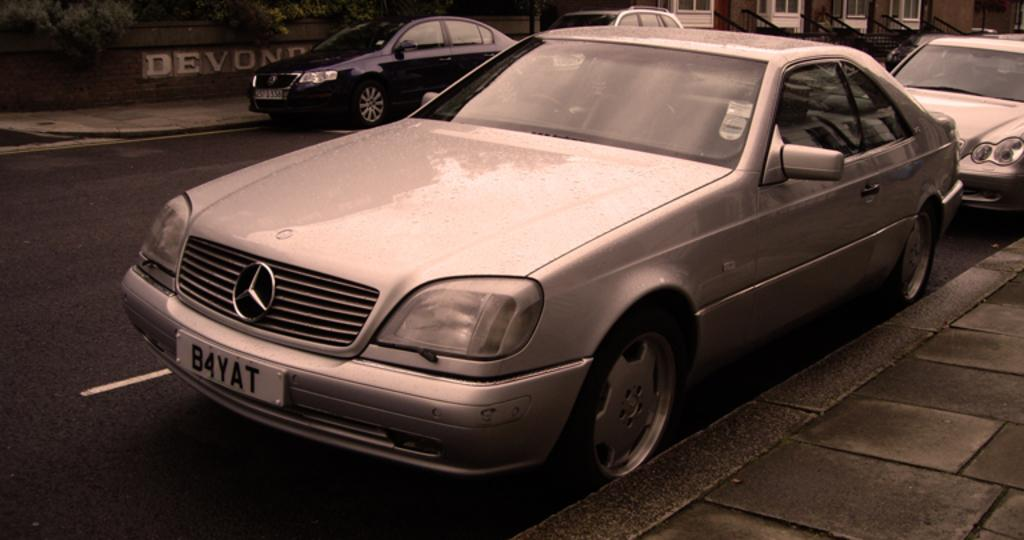<image>
Give a short and clear explanation of the subsequent image. A silver Mercedes is parked on the street and its license plate says B4YAT. 